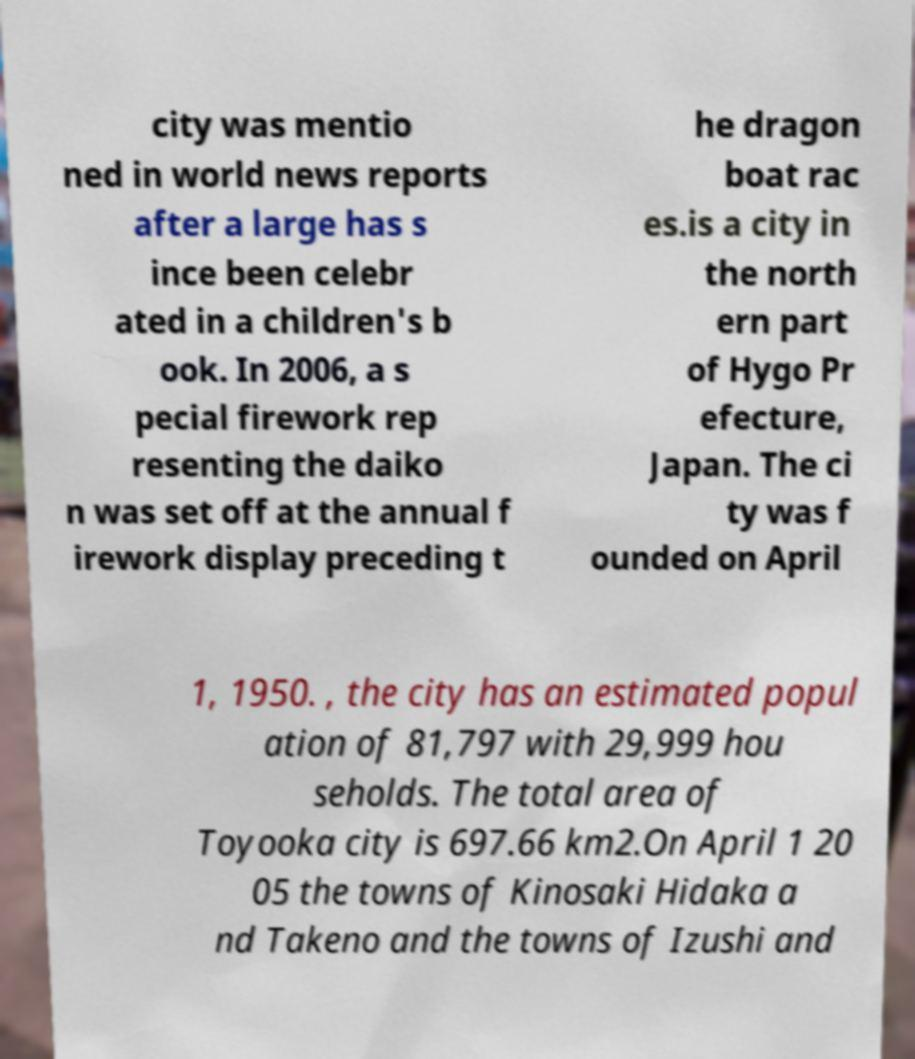There's text embedded in this image that I need extracted. Can you transcribe it verbatim? city was mentio ned in world news reports after a large has s ince been celebr ated in a children's b ook. In 2006, a s pecial firework rep resenting the daiko n was set off at the annual f irework display preceding t he dragon boat rac es.is a city in the north ern part of Hygo Pr efecture, Japan. The ci ty was f ounded on April 1, 1950. , the city has an estimated popul ation of 81,797 with 29,999 hou seholds. The total area of Toyooka city is 697.66 km2.On April 1 20 05 the towns of Kinosaki Hidaka a nd Takeno and the towns of Izushi and 